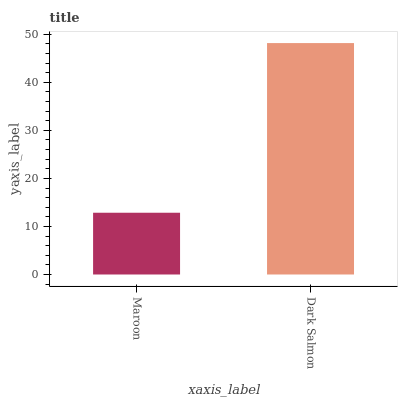Is Maroon the minimum?
Answer yes or no. Yes. Is Dark Salmon the maximum?
Answer yes or no. Yes. Is Dark Salmon the minimum?
Answer yes or no. No. Is Dark Salmon greater than Maroon?
Answer yes or no. Yes. Is Maroon less than Dark Salmon?
Answer yes or no. Yes. Is Maroon greater than Dark Salmon?
Answer yes or no. No. Is Dark Salmon less than Maroon?
Answer yes or no. No. Is Dark Salmon the high median?
Answer yes or no. Yes. Is Maroon the low median?
Answer yes or no. Yes. Is Maroon the high median?
Answer yes or no. No. Is Dark Salmon the low median?
Answer yes or no. No. 